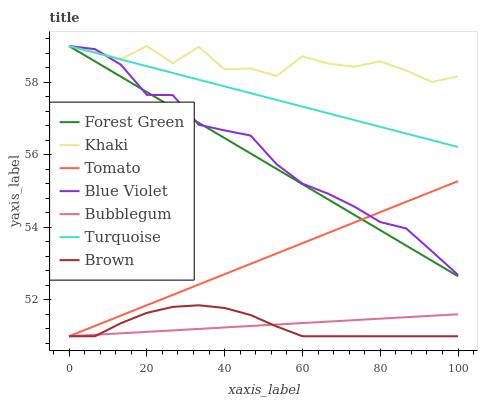Does Brown have the minimum area under the curve?
Answer yes or no. Yes. Does Khaki have the maximum area under the curve?
Answer yes or no. Yes. Does Turquoise have the minimum area under the curve?
Answer yes or no. No. Does Turquoise have the maximum area under the curve?
Answer yes or no. No. Is Tomato the smoothest?
Answer yes or no. Yes. Is Khaki the roughest?
Answer yes or no. Yes. Is Brown the smoothest?
Answer yes or no. No. Is Brown the roughest?
Answer yes or no. No. Does Turquoise have the lowest value?
Answer yes or no. No. Does Blue Violet have the highest value?
Answer yes or no. Yes. Does Brown have the highest value?
Answer yes or no. No. Is Tomato less than Khaki?
Answer yes or no. Yes. Is Turquoise greater than Tomato?
Answer yes or no. Yes. Does Tomato intersect Khaki?
Answer yes or no. No. 